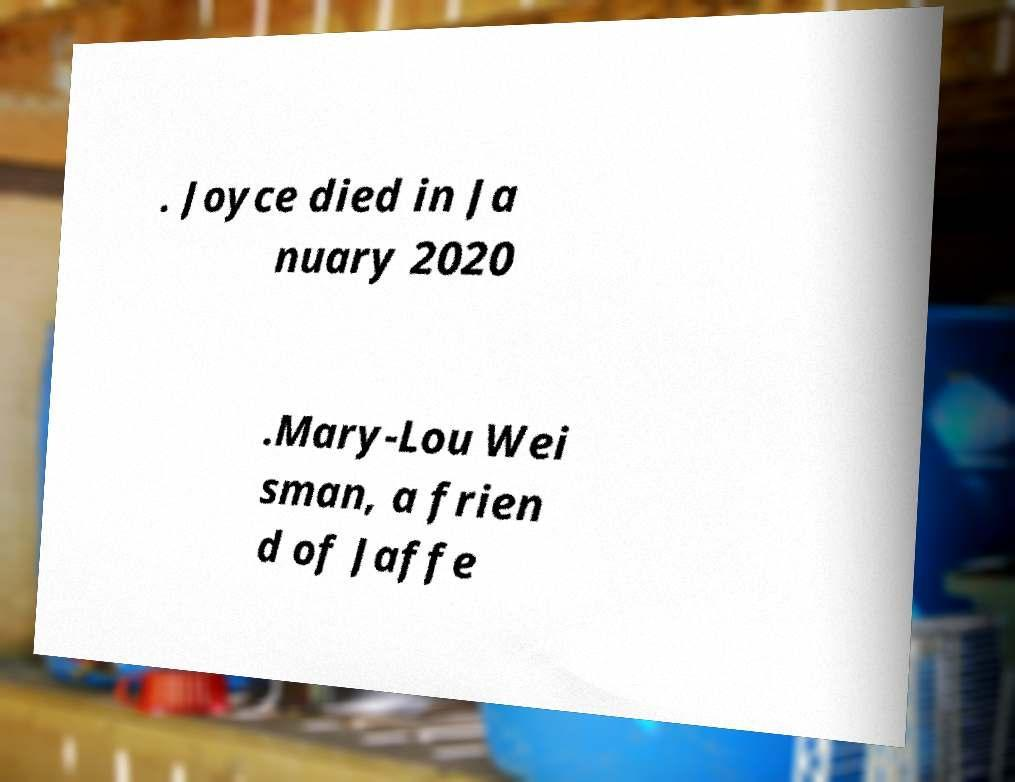Could you extract and type out the text from this image? . Joyce died in Ja nuary 2020 .Mary-Lou Wei sman, a frien d of Jaffe 